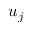<formula> <loc_0><loc_0><loc_500><loc_500>u _ { j }</formula> 